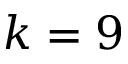Convert formula to latex. <formula><loc_0><loc_0><loc_500><loc_500>k = 9</formula> 